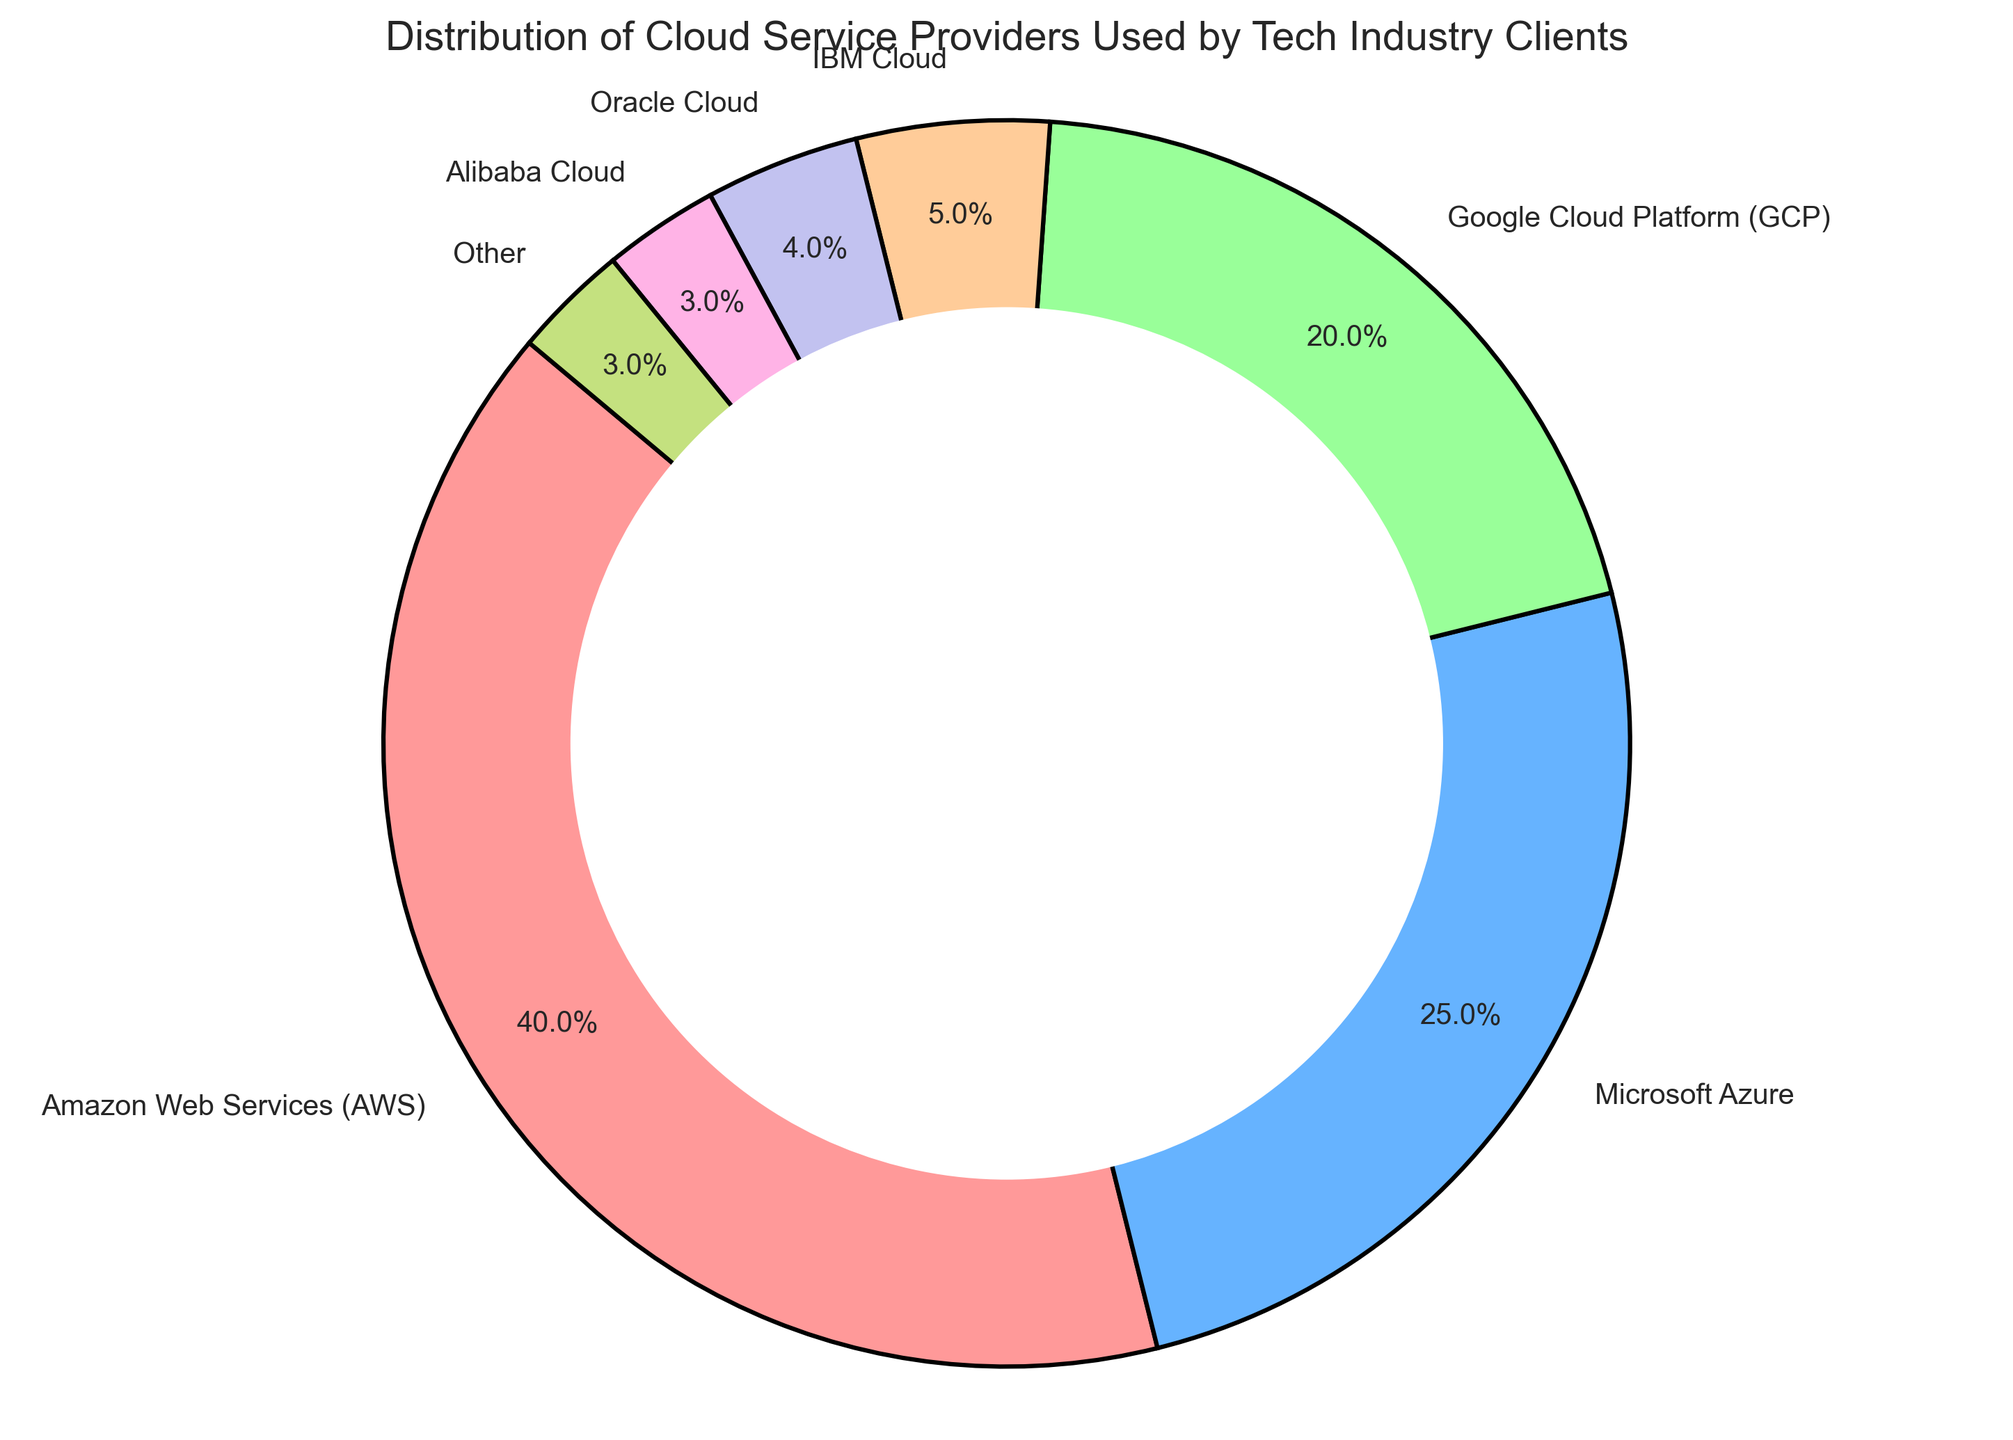What percentage of clients use Microsoft Azure? The pie chart shows the percentage distribution of different cloud service providers used by tech industry clients. Find the segment labeled "Microsoft Azure" and read its percentage value.
Answer: 25% Which two cloud service providers have the smallest market shares? From the pie chart, look for the segments with the smallest covered areas and their corresponding labels. The smallest segments are labeled "Alibaba Cloud" and "Other," each with their percentage values.
Answer: Alibaba Cloud and Other What is the combined percentage of clients using IBM Cloud and Oracle Cloud? From the pie chart, locate the segments labeled "IBM Cloud" and "Oracle Cloud" and read their percentages. Then, sum these percentages. IBM Cloud has 5% and Oracle Cloud has 4%. Adding these gives 5% + 4% = 9%.
Answer: 9% Is the percentage of clients using Google Cloud Platform greater than Microsoft Azure? To compare the percentages of clients using Google Cloud Platform (GCP) and Microsoft Azure, find their respective segments in the pie chart and compare their values. GCP is 20%, and Microsoft Azure is 25%.
Answer: No Which cloud service provider has the highest percentage of clients? The cloud service provider with the highest percentage will occupy the largest segment in the pie chart. The segment with the largest area is labeled "Amazon Web Services (AWS)" with a percentage value.
Answer: Amazon Web Services (AWS) By how much does AWS's percentage exceed GCP's percentage? Find the percentage values for AWS and GCP from the pie chart. AWS has 40%, and GCP has 20%. Subtract the percentage of GCP from AWS: 40% - 20% = 20%.
Answer: 20% What is the difference in percentage between clients using Microsoft Azure and those using IBM Cloud? Identify the percentage values for Microsoft Azure and IBM Cloud from the pie chart. Microsoft Azure has 25%, and IBM Cloud has 5%. Subtract IBM Cloud's percentage from Microsoft Azure's: 25% - 5% = 20%.
Answer: 20% What is the percentage of clients using less popular cloud providers (those with less than 10% usage)? Look for the segments in the pie chart with less than 10% usage: IBM Cloud (5%), Oracle Cloud (4%), Alibaba Cloud (3%), and Other (3%). Sum these percentages: 5% + 4% + 3% + 3% = 15%.
Answer: 15% 